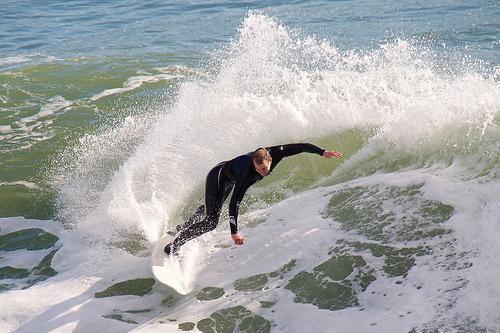How many people are pictured here?
Give a very brief answer. 1. How many animals are seen in this picture?
Give a very brief answer. 0. 